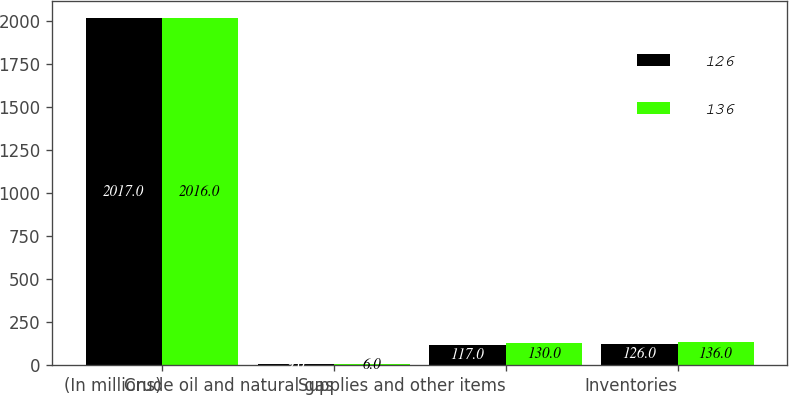<chart> <loc_0><loc_0><loc_500><loc_500><stacked_bar_chart><ecel><fcel>(In millions)<fcel>Crude oil and natural gas<fcel>Supplies and other items<fcel>Inventories<nl><fcel>126<fcel>2017<fcel>9<fcel>117<fcel>126<nl><fcel>136<fcel>2016<fcel>6<fcel>130<fcel>136<nl></chart> 